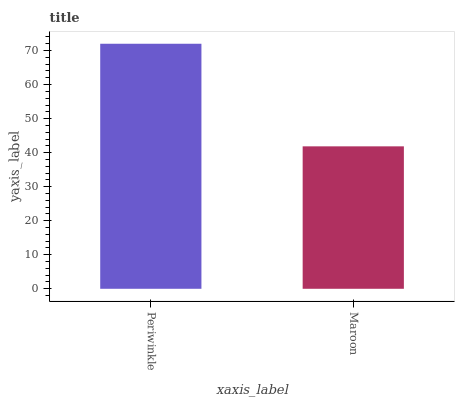Is Maroon the minimum?
Answer yes or no. Yes. Is Periwinkle the maximum?
Answer yes or no. Yes. Is Maroon the maximum?
Answer yes or no. No. Is Periwinkle greater than Maroon?
Answer yes or no. Yes. Is Maroon less than Periwinkle?
Answer yes or no. Yes. Is Maroon greater than Periwinkle?
Answer yes or no. No. Is Periwinkle less than Maroon?
Answer yes or no. No. Is Periwinkle the high median?
Answer yes or no. Yes. Is Maroon the low median?
Answer yes or no. Yes. Is Maroon the high median?
Answer yes or no. No. Is Periwinkle the low median?
Answer yes or no. No. 